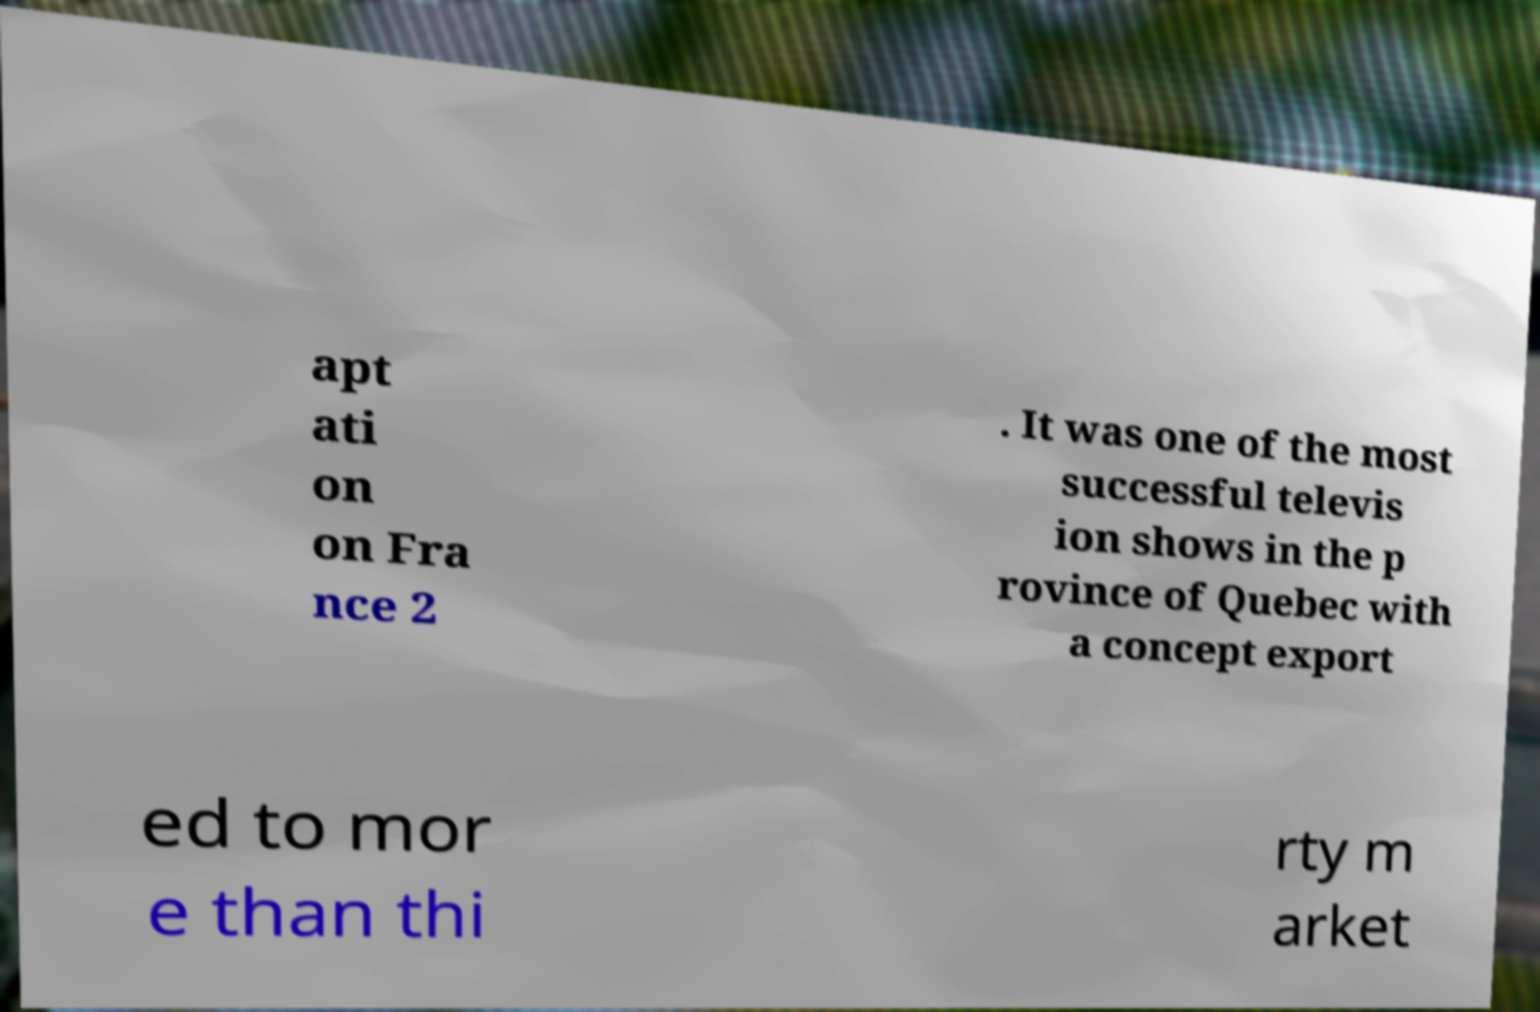Can you accurately transcribe the text from the provided image for me? apt ati on on Fra nce 2 . It was one of the most successful televis ion shows in the p rovince of Quebec with a concept export ed to mor e than thi rty m arket 